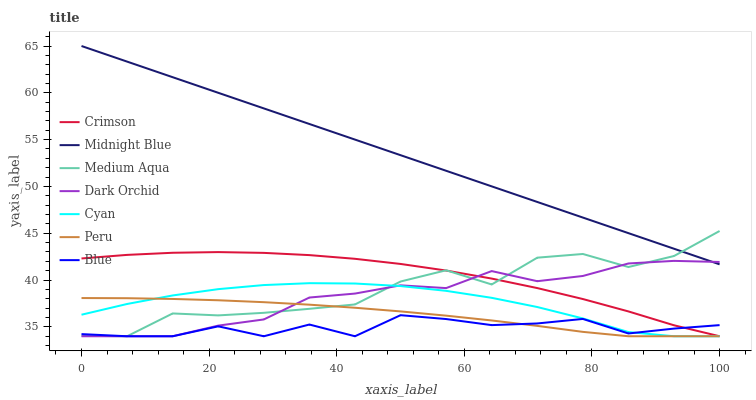Does Blue have the minimum area under the curve?
Answer yes or no. Yes. Does Midnight Blue have the maximum area under the curve?
Answer yes or no. Yes. Does Dark Orchid have the minimum area under the curve?
Answer yes or no. No. Does Dark Orchid have the maximum area under the curve?
Answer yes or no. No. Is Midnight Blue the smoothest?
Answer yes or no. Yes. Is Medium Aqua the roughest?
Answer yes or no. Yes. Is Dark Orchid the smoothest?
Answer yes or no. No. Is Dark Orchid the roughest?
Answer yes or no. No. Does Blue have the lowest value?
Answer yes or no. Yes. Does Midnight Blue have the lowest value?
Answer yes or no. No. Does Midnight Blue have the highest value?
Answer yes or no. Yes. Does Dark Orchid have the highest value?
Answer yes or no. No. Is Blue less than Midnight Blue?
Answer yes or no. Yes. Is Midnight Blue greater than Cyan?
Answer yes or no. Yes. Does Dark Orchid intersect Medium Aqua?
Answer yes or no. Yes. Is Dark Orchid less than Medium Aqua?
Answer yes or no. No. Is Dark Orchid greater than Medium Aqua?
Answer yes or no. No. Does Blue intersect Midnight Blue?
Answer yes or no. No. 